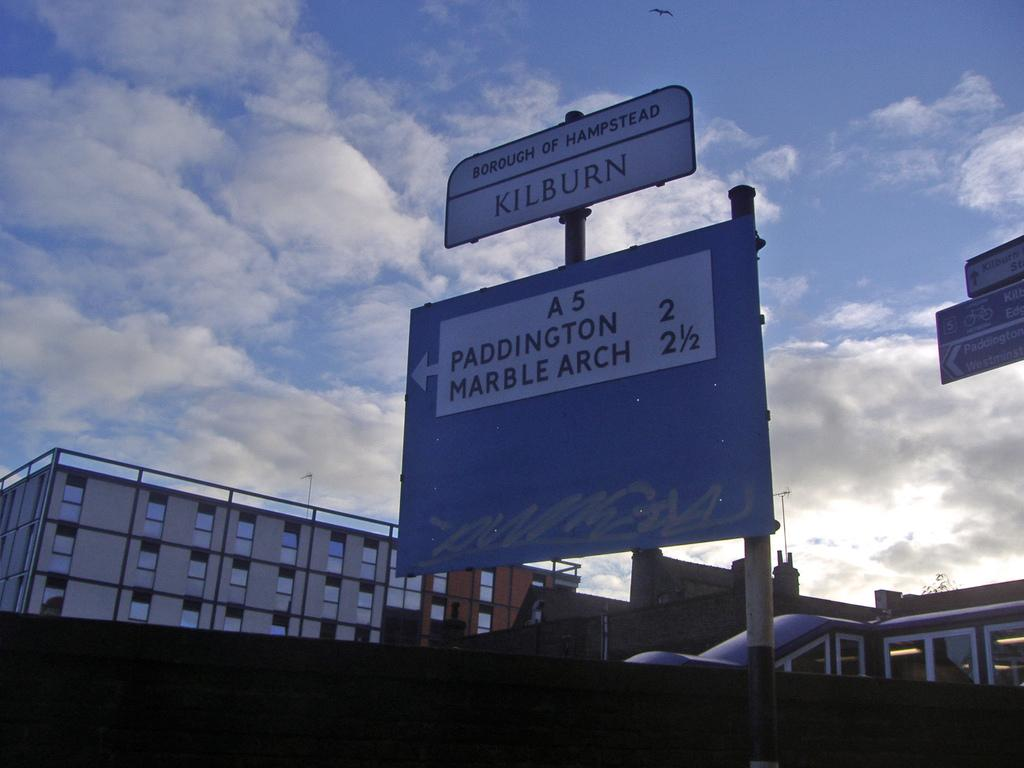<image>
Give a short and clear explanation of the subsequent image. A street sign showing the distances to Paddington and Marble Arch. 